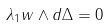Convert formula to latex. <formula><loc_0><loc_0><loc_500><loc_500>\lambda _ { 1 } w \wedge d \Delta = 0</formula> 